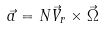<formula> <loc_0><loc_0><loc_500><loc_500>\vec { a } = N \vec { V } _ { r } \times \vec { \Omega }</formula> 